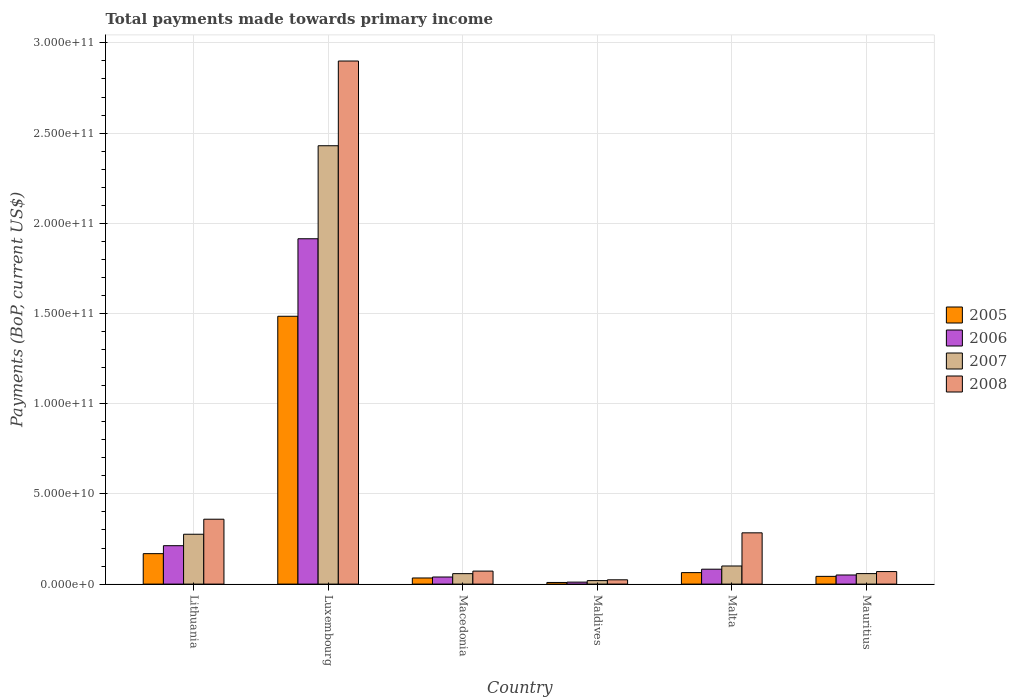How many groups of bars are there?
Ensure brevity in your answer.  6. What is the label of the 2nd group of bars from the left?
Provide a succinct answer. Luxembourg. What is the total payments made towards primary income in 2006 in Macedonia?
Make the answer very short. 3.93e+09. Across all countries, what is the maximum total payments made towards primary income in 2006?
Provide a succinct answer. 1.91e+11. Across all countries, what is the minimum total payments made towards primary income in 2005?
Keep it short and to the point. 9.10e+08. In which country was the total payments made towards primary income in 2006 maximum?
Provide a succinct answer. Luxembourg. In which country was the total payments made towards primary income in 2007 minimum?
Your response must be concise. Maldives. What is the total total payments made towards primary income in 2007 in the graph?
Provide a succinct answer. 2.94e+11. What is the difference between the total payments made towards primary income in 2008 in Lithuania and that in Luxembourg?
Your response must be concise. -2.54e+11. What is the difference between the total payments made towards primary income in 2005 in Lithuania and the total payments made towards primary income in 2006 in Macedonia?
Make the answer very short. 1.29e+1. What is the average total payments made towards primary income in 2005 per country?
Offer a very short reply. 3.00e+1. What is the difference between the total payments made towards primary income of/in 2006 and total payments made towards primary income of/in 2005 in Malta?
Your response must be concise. 1.90e+09. What is the ratio of the total payments made towards primary income in 2007 in Lithuania to that in Maldives?
Offer a very short reply. 14.23. Is the total payments made towards primary income in 2005 in Lithuania less than that in Luxembourg?
Give a very brief answer. Yes. What is the difference between the highest and the second highest total payments made towards primary income in 2007?
Offer a terse response. 2.33e+11. What is the difference between the highest and the lowest total payments made towards primary income in 2006?
Offer a very short reply. 1.90e+11. Is the sum of the total payments made towards primary income in 2005 in Luxembourg and Mauritius greater than the maximum total payments made towards primary income in 2007 across all countries?
Provide a short and direct response. No. What does the 4th bar from the right in Macedonia represents?
Provide a short and direct response. 2005. How many bars are there?
Your answer should be compact. 24. Are all the bars in the graph horizontal?
Give a very brief answer. No. Does the graph contain grids?
Offer a very short reply. Yes. How many legend labels are there?
Give a very brief answer. 4. What is the title of the graph?
Make the answer very short. Total payments made towards primary income. What is the label or title of the Y-axis?
Keep it short and to the point. Payments (BoP, current US$). What is the Payments (BoP, current US$) in 2005 in Lithuania?
Keep it short and to the point. 1.69e+1. What is the Payments (BoP, current US$) in 2006 in Lithuania?
Provide a succinct answer. 2.13e+1. What is the Payments (BoP, current US$) in 2007 in Lithuania?
Keep it short and to the point. 2.76e+1. What is the Payments (BoP, current US$) in 2008 in Lithuania?
Your answer should be very brief. 3.60e+1. What is the Payments (BoP, current US$) in 2005 in Luxembourg?
Give a very brief answer. 1.48e+11. What is the Payments (BoP, current US$) in 2006 in Luxembourg?
Ensure brevity in your answer.  1.91e+11. What is the Payments (BoP, current US$) in 2007 in Luxembourg?
Ensure brevity in your answer.  2.43e+11. What is the Payments (BoP, current US$) in 2008 in Luxembourg?
Provide a succinct answer. 2.90e+11. What is the Payments (BoP, current US$) of 2005 in Macedonia?
Your response must be concise. 3.39e+09. What is the Payments (BoP, current US$) in 2006 in Macedonia?
Your answer should be compact. 3.93e+09. What is the Payments (BoP, current US$) of 2007 in Macedonia?
Provide a short and direct response. 5.80e+09. What is the Payments (BoP, current US$) of 2008 in Macedonia?
Give a very brief answer. 7.21e+09. What is the Payments (BoP, current US$) of 2005 in Maldives?
Your response must be concise. 9.10e+08. What is the Payments (BoP, current US$) in 2006 in Maldives?
Offer a terse response. 1.10e+09. What is the Payments (BoP, current US$) of 2007 in Maldives?
Provide a short and direct response. 1.94e+09. What is the Payments (BoP, current US$) in 2008 in Maldives?
Offer a very short reply. 2.38e+09. What is the Payments (BoP, current US$) of 2005 in Malta?
Make the answer very short. 6.37e+09. What is the Payments (BoP, current US$) of 2006 in Malta?
Give a very brief answer. 8.26e+09. What is the Payments (BoP, current US$) in 2007 in Malta?
Your answer should be very brief. 1.00e+1. What is the Payments (BoP, current US$) in 2008 in Malta?
Your response must be concise. 2.84e+1. What is the Payments (BoP, current US$) in 2005 in Mauritius?
Offer a very short reply. 4.28e+09. What is the Payments (BoP, current US$) in 2006 in Mauritius?
Your response must be concise. 5.05e+09. What is the Payments (BoP, current US$) in 2007 in Mauritius?
Give a very brief answer. 5.82e+09. What is the Payments (BoP, current US$) of 2008 in Mauritius?
Make the answer very short. 6.95e+09. Across all countries, what is the maximum Payments (BoP, current US$) in 2005?
Your answer should be very brief. 1.48e+11. Across all countries, what is the maximum Payments (BoP, current US$) of 2006?
Your response must be concise. 1.91e+11. Across all countries, what is the maximum Payments (BoP, current US$) of 2007?
Ensure brevity in your answer.  2.43e+11. Across all countries, what is the maximum Payments (BoP, current US$) of 2008?
Provide a short and direct response. 2.90e+11. Across all countries, what is the minimum Payments (BoP, current US$) of 2005?
Provide a succinct answer. 9.10e+08. Across all countries, what is the minimum Payments (BoP, current US$) in 2006?
Keep it short and to the point. 1.10e+09. Across all countries, what is the minimum Payments (BoP, current US$) of 2007?
Keep it short and to the point. 1.94e+09. Across all countries, what is the minimum Payments (BoP, current US$) in 2008?
Keep it short and to the point. 2.38e+09. What is the total Payments (BoP, current US$) of 2005 in the graph?
Make the answer very short. 1.80e+11. What is the total Payments (BoP, current US$) in 2006 in the graph?
Offer a terse response. 2.31e+11. What is the total Payments (BoP, current US$) of 2007 in the graph?
Make the answer very short. 2.94e+11. What is the total Payments (BoP, current US$) of 2008 in the graph?
Make the answer very short. 3.71e+11. What is the difference between the Payments (BoP, current US$) of 2005 in Lithuania and that in Luxembourg?
Offer a terse response. -1.32e+11. What is the difference between the Payments (BoP, current US$) in 2006 in Lithuania and that in Luxembourg?
Provide a short and direct response. -1.70e+11. What is the difference between the Payments (BoP, current US$) in 2007 in Lithuania and that in Luxembourg?
Ensure brevity in your answer.  -2.15e+11. What is the difference between the Payments (BoP, current US$) of 2008 in Lithuania and that in Luxembourg?
Make the answer very short. -2.54e+11. What is the difference between the Payments (BoP, current US$) of 2005 in Lithuania and that in Macedonia?
Give a very brief answer. 1.35e+1. What is the difference between the Payments (BoP, current US$) of 2006 in Lithuania and that in Macedonia?
Provide a short and direct response. 1.74e+1. What is the difference between the Payments (BoP, current US$) in 2007 in Lithuania and that in Macedonia?
Offer a terse response. 2.18e+1. What is the difference between the Payments (BoP, current US$) in 2008 in Lithuania and that in Macedonia?
Provide a short and direct response. 2.88e+1. What is the difference between the Payments (BoP, current US$) in 2005 in Lithuania and that in Maldives?
Ensure brevity in your answer.  1.60e+1. What is the difference between the Payments (BoP, current US$) of 2006 in Lithuania and that in Maldives?
Your answer should be very brief. 2.02e+1. What is the difference between the Payments (BoP, current US$) of 2007 in Lithuania and that in Maldives?
Keep it short and to the point. 2.57e+1. What is the difference between the Payments (BoP, current US$) in 2008 in Lithuania and that in Maldives?
Offer a terse response. 3.36e+1. What is the difference between the Payments (BoP, current US$) of 2005 in Lithuania and that in Malta?
Provide a succinct answer. 1.05e+1. What is the difference between the Payments (BoP, current US$) of 2006 in Lithuania and that in Malta?
Ensure brevity in your answer.  1.30e+1. What is the difference between the Payments (BoP, current US$) of 2007 in Lithuania and that in Malta?
Give a very brief answer. 1.76e+1. What is the difference between the Payments (BoP, current US$) of 2008 in Lithuania and that in Malta?
Offer a very short reply. 7.55e+09. What is the difference between the Payments (BoP, current US$) in 2005 in Lithuania and that in Mauritius?
Make the answer very short. 1.26e+1. What is the difference between the Payments (BoP, current US$) in 2006 in Lithuania and that in Mauritius?
Give a very brief answer. 1.62e+1. What is the difference between the Payments (BoP, current US$) in 2007 in Lithuania and that in Mauritius?
Your answer should be very brief. 2.18e+1. What is the difference between the Payments (BoP, current US$) of 2008 in Lithuania and that in Mauritius?
Provide a succinct answer. 2.90e+1. What is the difference between the Payments (BoP, current US$) of 2005 in Luxembourg and that in Macedonia?
Make the answer very short. 1.45e+11. What is the difference between the Payments (BoP, current US$) in 2006 in Luxembourg and that in Macedonia?
Give a very brief answer. 1.87e+11. What is the difference between the Payments (BoP, current US$) of 2007 in Luxembourg and that in Macedonia?
Give a very brief answer. 2.37e+11. What is the difference between the Payments (BoP, current US$) in 2008 in Luxembourg and that in Macedonia?
Your response must be concise. 2.83e+11. What is the difference between the Payments (BoP, current US$) in 2005 in Luxembourg and that in Maldives?
Offer a terse response. 1.48e+11. What is the difference between the Payments (BoP, current US$) in 2006 in Luxembourg and that in Maldives?
Provide a succinct answer. 1.90e+11. What is the difference between the Payments (BoP, current US$) in 2007 in Luxembourg and that in Maldives?
Offer a very short reply. 2.41e+11. What is the difference between the Payments (BoP, current US$) of 2008 in Luxembourg and that in Maldives?
Provide a short and direct response. 2.88e+11. What is the difference between the Payments (BoP, current US$) of 2005 in Luxembourg and that in Malta?
Your answer should be compact. 1.42e+11. What is the difference between the Payments (BoP, current US$) of 2006 in Luxembourg and that in Malta?
Provide a succinct answer. 1.83e+11. What is the difference between the Payments (BoP, current US$) in 2007 in Luxembourg and that in Malta?
Make the answer very short. 2.33e+11. What is the difference between the Payments (BoP, current US$) of 2008 in Luxembourg and that in Malta?
Give a very brief answer. 2.62e+11. What is the difference between the Payments (BoP, current US$) of 2005 in Luxembourg and that in Mauritius?
Provide a succinct answer. 1.44e+11. What is the difference between the Payments (BoP, current US$) in 2006 in Luxembourg and that in Mauritius?
Give a very brief answer. 1.86e+11. What is the difference between the Payments (BoP, current US$) of 2007 in Luxembourg and that in Mauritius?
Make the answer very short. 2.37e+11. What is the difference between the Payments (BoP, current US$) in 2008 in Luxembourg and that in Mauritius?
Offer a terse response. 2.83e+11. What is the difference between the Payments (BoP, current US$) in 2005 in Macedonia and that in Maldives?
Your answer should be very brief. 2.48e+09. What is the difference between the Payments (BoP, current US$) in 2006 in Macedonia and that in Maldives?
Ensure brevity in your answer.  2.83e+09. What is the difference between the Payments (BoP, current US$) of 2007 in Macedonia and that in Maldives?
Keep it short and to the point. 3.86e+09. What is the difference between the Payments (BoP, current US$) of 2008 in Macedonia and that in Maldives?
Provide a short and direct response. 4.83e+09. What is the difference between the Payments (BoP, current US$) in 2005 in Macedonia and that in Malta?
Keep it short and to the point. -2.97e+09. What is the difference between the Payments (BoP, current US$) in 2006 in Macedonia and that in Malta?
Offer a very short reply. -4.33e+09. What is the difference between the Payments (BoP, current US$) in 2007 in Macedonia and that in Malta?
Your answer should be very brief. -4.24e+09. What is the difference between the Payments (BoP, current US$) of 2008 in Macedonia and that in Malta?
Offer a very short reply. -2.12e+1. What is the difference between the Payments (BoP, current US$) of 2005 in Macedonia and that in Mauritius?
Offer a terse response. -8.91e+08. What is the difference between the Payments (BoP, current US$) in 2006 in Macedonia and that in Mauritius?
Give a very brief answer. -1.12e+09. What is the difference between the Payments (BoP, current US$) in 2007 in Macedonia and that in Mauritius?
Your answer should be very brief. -1.97e+07. What is the difference between the Payments (BoP, current US$) of 2008 in Macedonia and that in Mauritius?
Ensure brevity in your answer.  2.59e+08. What is the difference between the Payments (BoP, current US$) in 2005 in Maldives and that in Malta?
Keep it short and to the point. -5.46e+09. What is the difference between the Payments (BoP, current US$) in 2006 in Maldives and that in Malta?
Your response must be concise. -7.16e+09. What is the difference between the Payments (BoP, current US$) in 2007 in Maldives and that in Malta?
Make the answer very short. -8.10e+09. What is the difference between the Payments (BoP, current US$) of 2008 in Maldives and that in Malta?
Ensure brevity in your answer.  -2.60e+1. What is the difference between the Payments (BoP, current US$) in 2005 in Maldives and that in Mauritius?
Your answer should be very brief. -3.37e+09. What is the difference between the Payments (BoP, current US$) of 2006 in Maldives and that in Mauritius?
Provide a short and direct response. -3.95e+09. What is the difference between the Payments (BoP, current US$) in 2007 in Maldives and that in Mauritius?
Offer a terse response. -3.88e+09. What is the difference between the Payments (BoP, current US$) in 2008 in Maldives and that in Mauritius?
Ensure brevity in your answer.  -4.57e+09. What is the difference between the Payments (BoP, current US$) in 2005 in Malta and that in Mauritius?
Keep it short and to the point. 2.08e+09. What is the difference between the Payments (BoP, current US$) of 2006 in Malta and that in Mauritius?
Offer a very short reply. 3.21e+09. What is the difference between the Payments (BoP, current US$) of 2007 in Malta and that in Mauritius?
Ensure brevity in your answer.  4.22e+09. What is the difference between the Payments (BoP, current US$) of 2008 in Malta and that in Mauritius?
Your answer should be very brief. 2.15e+1. What is the difference between the Payments (BoP, current US$) in 2005 in Lithuania and the Payments (BoP, current US$) in 2006 in Luxembourg?
Make the answer very short. -1.75e+11. What is the difference between the Payments (BoP, current US$) of 2005 in Lithuania and the Payments (BoP, current US$) of 2007 in Luxembourg?
Offer a terse response. -2.26e+11. What is the difference between the Payments (BoP, current US$) in 2005 in Lithuania and the Payments (BoP, current US$) in 2008 in Luxembourg?
Your answer should be very brief. -2.73e+11. What is the difference between the Payments (BoP, current US$) of 2006 in Lithuania and the Payments (BoP, current US$) of 2007 in Luxembourg?
Ensure brevity in your answer.  -2.22e+11. What is the difference between the Payments (BoP, current US$) of 2006 in Lithuania and the Payments (BoP, current US$) of 2008 in Luxembourg?
Make the answer very short. -2.69e+11. What is the difference between the Payments (BoP, current US$) in 2007 in Lithuania and the Payments (BoP, current US$) in 2008 in Luxembourg?
Give a very brief answer. -2.62e+11. What is the difference between the Payments (BoP, current US$) of 2005 in Lithuania and the Payments (BoP, current US$) of 2006 in Macedonia?
Your response must be concise. 1.29e+1. What is the difference between the Payments (BoP, current US$) of 2005 in Lithuania and the Payments (BoP, current US$) of 2007 in Macedonia?
Provide a succinct answer. 1.11e+1. What is the difference between the Payments (BoP, current US$) in 2005 in Lithuania and the Payments (BoP, current US$) in 2008 in Macedonia?
Ensure brevity in your answer.  9.67e+09. What is the difference between the Payments (BoP, current US$) in 2006 in Lithuania and the Payments (BoP, current US$) in 2007 in Macedonia?
Your answer should be compact. 1.55e+1. What is the difference between the Payments (BoP, current US$) in 2006 in Lithuania and the Payments (BoP, current US$) in 2008 in Macedonia?
Offer a terse response. 1.41e+1. What is the difference between the Payments (BoP, current US$) in 2007 in Lithuania and the Payments (BoP, current US$) in 2008 in Macedonia?
Provide a succinct answer. 2.04e+1. What is the difference between the Payments (BoP, current US$) in 2005 in Lithuania and the Payments (BoP, current US$) in 2006 in Maldives?
Give a very brief answer. 1.58e+1. What is the difference between the Payments (BoP, current US$) in 2005 in Lithuania and the Payments (BoP, current US$) in 2007 in Maldives?
Your answer should be compact. 1.49e+1. What is the difference between the Payments (BoP, current US$) in 2005 in Lithuania and the Payments (BoP, current US$) in 2008 in Maldives?
Your response must be concise. 1.45e+1. What is the difference between the Payments (BoP, current US$) in 2006 in Lithuania and the Payments (BoP, current US$) in 2007 in Maldives?
Keep it short and to the point. 1.93e+1. What is the difference between the Payments (BoP, current US$) of 2006 in Lithuania and the Payments (BoP, current US$) of 2008 in Maldives?
Your answer should be compact. 1.89e+1. What is the difference between the Payments (BoP, current US$) of 2007 in Lithuania and the Payments (BoP, current US$) of 2008 in Maldives?
Your answer should be very brief. 2.53e+1. What is the difference between the Payments (BoP, current US$) in 2005 in Lithuania and the Payments (BoP, current US$) in 2006 in Malta?
Give a very brief answer. 8.62e+09. What is the difference between the Payments (BoP, current US$) of 2005 in Lithuania and the Payments (BoP, current US$) of 2007 in Malta?
Your answer should be compact. 6.84e+09. What is the difference between the Payments (BoP, current US$) of 2005 in Lithuania and the Payments (BoP, current US$) of 2008 in Malta?
Offer a very short reply. -1.15e+1. What is the difference between the Payments (BoP, current US$) in 2006 in Lithuania and the Payments (BoP, current US$) in 2007 in Malta?
Your answer should be very brief. 1.12e+1. What is the difference between the Payments (BoP, current US$) of 2006 in Lithuania and the Payments (BoP, current US$) of 2008 in Malta?
Offer a very short reply. -7.13e+09. What is the difference between the Payments (BoP, current US$) of 2007 in Lithuania and the Payments (BoP, current US$) of 2008 in Malta?
Offer a terse response. -7.77e+08. What is the difference between the Payments (BoP, current US$) in 2005 in Lithuania and the Payments (BoP, current US$) in 2006 in Mauritius?
Provide a succinct answer. 1.18e+1. What is the difference between the Payments (BoP, current US$) in 2005 in Lithuania and the Payments (BoP, current US$) in 2007 in Mauritius?
Provide a short and direct response. 1.11e+1. What is the difference between the Payments (BoP, current US$) in 2005 in Lithuania and the Payments (BoP, current US$) in 2008 in Mauritius?
Make the answer very short. 9.93e+09. What is the difference between the Payments (BoP, current US$) in 2006 in Lithuania and the Payments (BoP, current US$) in 2007 in Mauritius?
Keep it short and to the point. 1.55e+1. What is the difference between the Payments (BoP, current US$) of 2006 in Lithuania and the Payments (BoP, current US$) of 2008 in Mauritius?
Your answer should be very brief. 1.43e+1. What is the difference between the Payments (BoP, current US$) of 2007 in Lithuania and the Payments (BoP, current US$) of 2008 in Mauritius?
Offer a terse response. 2.07e+1. What is the difference between the Payments (BoP, current US$) of 2005 in Luxembourg and the Payments (BoP, current US$) of 2006 in Macedonia?
Provide a short and direct response. 1.45e+11. What is the difference between the Payments (BoP, current US$) of 2005 in Luxembourg and the Payments (BoP, current US$) of 2007 in Macedonia?
Your answer should be compact. 1.43e+11. What is the difference between the Payments (BoP, current US$) in 2005 in Luxembourg and the Payments (BoP, current US$) in 2008 in Macedonia?
Make the answer very short. 1.41e+11. What is the difference between the Payments (BoP, current US$) in 2006 in Luxembourg and the Payments (BoP, current US$) in 2007 in Macedonia?
Offer a very short reply. 1.86e+11. What is the difference between the Payments (BoP, current US$) of 2006 in Luxembourg and the Payments (BoP, current US$) of 2008 in Macedonia?
Your answer should be very brief. 1.84e+11. What is the difference between the Payments (BoP, current US$) in 2007 in Luxembourg and the Payments (BoP, current US$) in 2008 in Macedonia?
Your answer should be compact. 2.36e+11. What is the difference between the Payments (BoP, current US$) of 2005 in Luxembourg and the Payments (BoP, current US$) of 2006 in Maldives?
Provide a short and direct response. 1.47e+11. What is the difference between the Payments (BoP, current US$) of 2005 in Luxembourg and the Payments (BoP, current US$) of 2007 in Maldives?
Make the answer very short. 1.47e+11. What is the difference between the Payments (BoP, current US$) of 2005 in Luxembourg and the Payments (BoP, current US$) of 2008 in Maldives?
Keep it short and to the point. 1.46e+11. What is the difference between the Payments (BoP, current US$) in 2006 in Luxembourg and the Payments (BoP, current US$) in 2007 in Maldives?
Provide a short and direct response. 1.89e+11. What is the difference between the Payments (BoP, current US$) in 2006 in Luxembourg and the Payments (BoP, current US$) in 2008 in Maldives?
Make the answer very short. 1.89e+11. What is the difference between the Payments (BoP, current US$) of 2007 in Luxembourg and the Payments (BoP, current US$) of 2008 in Maldives?
Your response must be concise. 2.41e+11. What is the difference between the Payments (BoP, current US$) of 2005 in Luxembourg and the Payments (BoP, current US$) of 2006 in Malta?
Your answer should be very brief. 1.40e+11. What is the difference between the Payments (BoP, current US$) in 2005 in Luxembourg and the Payments (BoP, current US$) in 2007 in Malta?
Ensure brevity in your answer.  1.38e+11. What is the difference between the Payments (BoP, current US$) in 2005 in Luxembourg and the Payments (BoP, current US$) in 2008 in Malta?
Ensure brevity in your answer.  1.20e+11. What is the difference between the Payments (BoP, current US$) of 2006 in Luxembourg and the Payments (BoP, current US$) of 2007 in Malta?
Your response must be concise. 1.81e+11. What is the difference between the Payments (BoP, current US$) of 2006 in Luxembourg and the Payments (BoP, current US$) of 2008 in Malta?
Give a very brief answer. 1.63e+11. What is the difference between the Payments (BoP, current US$) in 2007 in Luxembourg and the Payments (BoP, current US$) in 2008 in Malta?
Give a very brief answer. 2.15e+11. What is the difference between the Payments (BoP, current US$) in 2005 in Luxembourg and the Payments (BoP, current US$) in 2006 in Mauritius?
Your answer should be compact. 1.43e+11. What is the difference between the Payments (BoP, current US$) in 2005 in Luxembourg and the Payments (BoP, current US$) in 2007 in Mauritius?
Your answer should be very brief. 1.43e+11. What is the difference between the Payments (BoP, current US$) of 2005 in Luxembourg and the Payments (BoP, current US$) of 2008 in Mauritius?
Provide a succinct answer. 1.42e+11. What is the difference between the Payments (BoP, current US$) in 2006 in Luxembourg and the Payments (BoP, current US$) in 2007 in Mauritius?
Your answer should be very brief. 1.86e+11. What is the difference between the Payments (BoP, current US$) in 2006 in Luxembourg and the Payments (BoP, current US$) in 2008 in Mauritius?
Your answer should be compact. 1.84e+11. What is the difference between the Payments (BoP, current US$) in 2007 in Luxembourg and the Payments (BoP, current US$) in 2008 in Mauritius?
Keep it short and to the point. 2.36e+11. What is the difference between the Payments (BoP, current US$) of 2005 in Macedonia and the Payments (BoP, current US$) of 2006 in Maldives?
Provide a succinct answer. 2.29e+09. What is the difference between the Payments (BoP, current US$) of 2005 in Macedonia and the Payments (BoP, current US$) of 2007 in Maldives?
Ensure brevity in your answer.  1.45e+09. What is the difference between the Payments (BoP, current US$) of 2005 in Macedonia and the Payments (BoP, current US$) of 2008 in Maldives?
Your response must be concise. 1.01e+09. What is the difference between the Payments (BoP, current US$) in 2006 in Macedonia and the Payments (BoP, current US$) in 2007 in Maldives?
Make the answer very short. 1.99e+09. What is the difference between the Payments (BoP, current US$) in 2006 in Macedonia and the Payments (BoP, current US$) in 2008 in Maldives?
Offer a terse response. 1.55e+09. What is the difference between the Payments (BoP, current US$) in 2007 in Macedonia and the Payments (BoP, current US$) in 2008 in Maldives?
Your response must be concise. 3.42e+09. What is the difference between the Payments (BoP, current US$) in 2005 in Macedonia and the Payments (BoP, current US$) in 2006 in Malta?
Your answer should be compact. -4.87e+09. What is the difference between the Payments (BoP, current US$) in 2005 in Macedonia and the Payments (BoP, current US$) in 2007 in Malta?
Offer a very short reply. -6.65e+09. What is the difference between the Payments (BoP, current US$) of 2005 in Macedonia and the Payments (BoP, current US$) of 2008 in Malta?
Your answer should be very brief. -2.50e+1. What is the difference between the Payments (BoP, current US$) of 2006 in Macedonia and the Payments (BoP, current US$) of 2007 in Malta?
Give a very brief answer. -6.11e+09. What is the difference between the Payments (BoP, current US$) in 2006 in Macedonia and the Payments (BoP, current US$) in 2008 in Malta?
Keep it short and to the point. -2.45e+1. What is the difference between the Payments (BoP, current US$) in 2007 in Macedonia and the Payments (BoP, current US$) in 2008 in Malta?
Your response must be concise. -2.26e+1. What is the difference between the Payments (BoP, current US$) in 2005 in Macedonia and the Payments (BoP, current US$) in 2006 in Mauritius?
Your answer should be compact. -1.66e+09. What is the difference between the Payments (BoP, current US$) in 2005 in Macedonia and the Payments (BoP, current US$) in 2007 in Mauritius?
Your answer should be very brief. -2.43e+09. What is the difference between the Payments (BoP, current US$) in 2005 in Macedonia and the Payments (BoP, current US$) in 2008 in Mauritius?
Your response must be concise. -3.55e+09. What is the difference between the Payments (BoP, current US$) in 2006 in Macedonia and the Payments (BoP, current US$) in 2007 in Mauritius?
Provide a short and direct response. -1.89e+09. What is the difference between the Payments (BoP, current US$) of 2006 in Macedonia and the Payments (BoP, current US$) of 2008 in Mauritius?
Your answer should be compact. -3.02e+09. What is the difference between the Payments (BoP, current US$) in 2007 in Macedonia and the Payments (BoP, current US$) in 2008 in Mauritius?
Give a very brief answer. -1.15e+09. What is the difference between the Payments (BoP, current US$) of 2005 in Maldives and the Payments (BoP, current US$) of 2006 in Malta?
Offer a very short reply. -7.35e+09. What is the difference between the Payments (BoP, current US$) in 2005 in Maldives and the Payments (BoP, current US$) in 2007 in Malta?
Make the answer very short. -9.13e+09. What is the difference between the Payments (BoP, current US$) of 2005 in Maldives and the Payments (BoP, current US$) of 2008 in Malta?
Offer a very short reply. -2.75e+1. What is the difference between the Payments (BoP, current US$) in 2006 in Maldives and the Payments (BoP, current US$) in 2007 in Malta?
Keep it short and to the point. -8.94e+09. What is the difference between the Payments (BoP, current US$) of 2006 in Maldives and the Payments (BoP, current US$) of 2008 in Malta?
Offer a terse response. -2.73e+1. What is the difference between the Payments (BoP, current US$) in 2007 in Maldives and the Payments (BoP, current US$) in 2008 in Malta?
Offer a very short reply. -2.65e+1. What is the difference between the Payments (BoP, current US$) in 2005 in Maldives and the Payments (BoP, current US$) in 2006 in Mauritius?
Your answer should be compact. -4.14e+09. What is the difference between the Payments (BoP, current US$) of 2005 in Maldives and the Payments (BoP, current US$) of 2007 in Mauritius?
Give a very brief answer. -4.91e+09. What is the difference between the Payments (BoP, current US$) in 2005 in Maldives and the Payments (BoP, current US$) in 2008 in Mauritius?
Keep it short and to the point. -6.04e+09. What is the difference between the Payments (BoP, current US$) of 2006 in Maldives and the Payments (BoP, current US$) of 2007 in Mauritius?
Provide a short and direct response. -4.72e+09. What is the difference between the Payments (BoP, current US$) of 2006 in Maldives and the Payments (BoP, current US$) of 2008 in Mauritius?
Provide a short and direct response. -5.84e+09. What is the difference between the Payments (BoP, current US$) in 2007 in Maldives and the Payments (BoP, current US$) in 2008 in Mauritius?
Make the answer very short. -5.00e+09. What is the difference between the Payments (BoP, current US$) of 2005 in Malta and the Payments (BoP, current US$) of 2006 in Mauritius?
Your answer should be compact. 1.32e+09. What is the difference between the Payments (BoP, current US$) of 2005 in Malta and the Payments (BoP, current US$) of 2007 in Mauritius?
Your response must be concise. 5.49e+08. What is the difference between the Payments (BoP, current US$) of 2005 in Malta and the Payments (BoP, current US$) of 2008 in Mauritius?
Make the answer very short. -5.81e+08. What is the difference between the Payments (BoP, current US$) of 2006 in Malta and the Payments (BoP, current US$) of 2007 in Mauritius?
Offer a terse response. 2.45e+09. What is the difference between the Payments (BoP, current US$) of 2006 in Malta and the Payments (BoP, current US$) of 2008 in Mauritius?
Offer a terse response. 1.32e+09. What is the difference between the Payments (BoP, current US$) in 2007 in Malta and the Payments (BoP, current US$) in 2008 in Mauritius?
Provide a short and direct response. 3.09e+09. What is the average Payments (BoP, current US$) in 2005 per country?
Ensure brevity in your answer.  3.00e+1. What is the average Payments (BoP, current US$) in 2006 per country?
Ensure brevity in your answer.  3.85e+1. What is the average Payments (BoP, current US$) of 2007 per country?
Keep it short and to the point. 4.90e+1. What is the average Payments (BoP, current US$) of 2008 per country?
Provide a short and direct response. 6.18e+1. What is the difference between the Payments (BoP, current US$) of 2005 and Payments (BoP, current US$) of 2006 in Lithuania?
Keep it short and to the point. -4.41e+09. What is the difference between the Payments (BoP, current US$) in 2005 and Payments (BoP, current US$) in 2007 in Lithuania?
Provide a short and direct response. -1.08e+1. What is the difference between the Payments (BoP, current US$) in 2005 and Payments (BoP, current US$) in 2008 in Lithuania?
Make the answer very short. -1.91e+1. What is the difference between the Payments (BoP, current US$) in 2006 and Payments (BoP, current US$) in 2007 in Lithuania?
Your response must be concise. -6.35e+09. What is the difference between the Payments (BoP, current US$) of 2006 and Payments (BoP, current US$) of 2008 in Lithuania?
Provide a succinct answer. -1.47e+1. What is the difference between the Payments (BoP, current US$) in 2007 and Payments (BoP, current US$) in 2008 in Lithuania?
Your response must be concise. -8.33e+09. What is the difference between the Payments (BoP, current US$) in 2005 and Payments (BoP, current US$) in 2006 in Luxembourg?
Your answer should be compact. -4.30e+1. What is the difference between the Payments (BoP, current US$) of 2005 and Payments (BoP, current US$) of 2007 in Luxembourg?
Provide a short and direct response. -9.45e+1. What is the difference between the Payments (BoP, current US$) of 2005 and Payments (BoP, current US$) of 2008 in Luxembourg?
Your answer should be compact. -1.41e+11. What is the difference between the Payments (BoP, current US$) of 2006 and Payments (BoP, current US$) of 2007 in Luxembourg?
Your answer should be compact. -5.16e+1. What is the difference between the Payments (BoP, current US$) of 2006 and Payments (BoP, current US$) of 2008 in Luxembourg?
Your response must be concise. -9.85e+1. What is the difference between the Payments (BoP, current US$) in 2007 and Payments (BoP, current US$) in 2008 in Luxembourg?
Provide a succinct answer. -4.70e+1. What is the difference between the Payments (BoP, current US$) in 2005 and Payments (BoP, current US$) in 2006 in Macedonia?
Give a very brief answer. -5.40e+08. What is the difference between the Payments (BoP, current US$) of 2005 and Payments (BoP, current US$) of 2007 in Macedonia?
Keep it short and to the point. -2.41e+09. What is the difference between the Payments (BoP, current US$) in 2005 and Payments (BoP, current US$) in 2008 in Macedonia?
Keep it short and to the point. -3.81e+09. What is the difference between the Payments (BoP, current US$) in 2006 and Payments (BoP, current US$) in 2007 in Macedonia?
Ensure brevity in your answer.  -1.87e+09. What is the difference between the Payments (BoP, current US$) in 2006 and Payments (BoP, current US$) in 2008 in Macedonia?
Your answer should be compact. -3.27e+09. What is the difference between the Payments (BoP, current US$) in 2007 and Payments (BoP, current US$) in 2008 in Macedonia?
Make the answer very short. -1.41e+09. What is the difference between the Payments (BoP, current US$) of 2005 and Payments (BoP, current US$) of 2006 in Maldives?
Ensure brevity in your answer.  -1.92e+08. What is the difference between the Payments (BoP, current US$) of 2005 and Payments (BoP, current US$) of 2007 in Maldives?
Keep it short and to the point. -1.03e+09. What is the difference between the Payments (BoP, current US$) in 2005 and Payments (BoP, current US$) in 2008 in Maldives?
Your answer should be very brief. -1.47e+09. What is the difference between the Payments (BoP, current US$) in 2006 and Payments (BoP, current US$) in 2007 in Maldives?
Provide a succinct answer. -8.40e+08. What is the difference between the Payments (BoP, current US$) of 2006 and Payments (BoP, current US$) of 2008 in Maldives?
Ensure brevity in your answer.  -1.28e+09. What is the difference between the Payments (BoP, current US$) of 2007 and Payments (BoP, current US$) of 2008 in Maldives?
Provide a short and direct response. -4.38e+08. What is the difference between the Payments (BoP, current US$) in 2005 and Payments (BoP, current US$) in 2006 in Malta?
Your response must be concise. -1.90e+09. What is the difference between the Payments (BoP, current US$) in 2005 and Payments (BoP, current US$) in 2007 in Malta?
Provide a short and direct response. -3.67e+09. What is the difference between the Payments (BoP, current US$) of 2005 and Payments (BoP, current US$) of 2008 in Malta?
Your answer should be very brief. -2.21e+1. What is the difference between the Payments (BoP, current US$) of 2006 and Payments (BoP, current US$) of 2007 in Malta?
Provide a succinct answer. -1.78e+09. What is the difference between the Payments (BoP, current US$) of 2006 and Payments (BoP, current US$) of 2008 in Malta?
Give a very brief answer. -2.02e+1. What is the difference between the Payments (BoP, current US$) in 2007 and Payments (BoP, current US$) in 2008 in Malta?
Keep it short and to the point. -1.84e+1. What is the difference between the Payments (BoP, current US$) in 2005 and Payments (BoP, current US$) in 2006 in Mauritius?
Your answer should be compact. -7.65e+08. What is the difference between the Payments (BoP, current US$) in 2005 and Payments (BoP, current US$) in 2007 in Mauritius?
Your answer should be very brief. -1.53e+09. What is the difference between the Payments (BoP, current US$) of 2005 and Payments (BoP, current US$) of 2008 in Mauritius?
Make the answer very short. -2.66e+09. What is the difference between the Payments (BoP, current US$) in 2006 and Payments (BoP, current US$) in 2007 in Mauritius?
Make the answer very short. -7.69e+08. What is the difference between the Payments (BoP, current US$) of 2006 and Payments (BoP, current US$) of 2008 in Mauritius?
Keep it short and to the point. -1.90e+09. What is the difference between the Payments (BoP, current US$) in 2007 and Payments (BoP, current US$) in 2008 in Mauritius?
Provide a short and direct response. -1.13e+09. What is the ratio of the Payments (BoP, current US$) of 2005 in Lithuania to that in Luxembourg?
Offer a very short reply. 0.11. What is the ratio of the Payments (BoP, current US$) in 2006 in Lithuania to that in Luxembourg?
Ensure brevity in your answer.  0.11. What is the ratio of the Payments (BoP, current US$) of 2007 in Lithuania to that in Luxembourg?
Ensure brevity in your answer.  0.11. What is the ratio of the Payments (BoP, current US$) of 2008 in Lithuania to that in Luxembourg?
Provide a short and direct response. 0.12. What is the ratio of the Payments (BoP, current US$) in 2005 in Lithuania to that in Macedonia?
Provide a short and direct response. 4.98. What is the ratio of the Payments (BoP, current US$) in 2006 in Lithuania to that in Macedonia?
Your answer should be compact. 5.41. What is the ratio of the Payments (BoP, current US$) of 2007 in Lithuania to that in Macedonia?
Provide a succinct answer. 4.77. What is the ratio of the Payments (BoP, current US$) of 2008 in Lithuania to that in Macedonia?
Your answer should be compact. 4.99. What is the ratio of the Payments (BoP, current US$) of 2005 in Lithuania to that in Maldives?
Offer a terse response. 18.54. What is the ratio of the Payments (BoP, current US$) of 2006 in Lithuania to that in Maldives?
Your answer should be very brief. 19.31. What is the ratio of the Payments (BoP, current US$) in 2007 in Lithuania to that in Maldives?
Offer a terse response. 14.23. What is the ratio of the Payments (BoP, current US$) of 2008 in Lithuania to that in Maldives?
Provide a succinct answer. 15.11. What is the ratio of the Payments (BoP, current US$) in 2005 in Lithuania to that in Malta?
Offer a terse response. 2.65. What is the ratio of the Payments (BoP, current US$) of 2006 in Lithuania to that in Malta?
Provide a succinct answer. 2.58. What is the ratio of the Payments (BoP, current US$) in 2007 in Lithuania to that in Malta?
Your response must be concise. 2.75. What is the ratio of the Payments (BoP, current US$) of 2008 in Lithuania to that in Malta?
Ensure brevity in your answer.  1.27. What is the ratio of the Payments (BoP, current US$) in 2005 in Lithuania to that in Mauritius?
Keep it short and to the point. 3.94. What is the ratio of the Payments (BoP, current US$) of 2006 in Lithuania to that in Mauritius?
Make the answer very short. 4.22. What is the ratio of the Payments (BoP, current US$) in 2007 in Lithuania to that in Mauritius?
Offer a very short reply. 4.75. What is the ratio of the Payments (BoP, current US$) of 2008 in Lithuania to that in Mauritius?
Make the answer very short. 5.18. What is the ratio of the Payments (BoP, current US$) of 2005 in Luxembourg to that in Macedonia?
Your answer should be compact. 43.76. What is the ratio of the Payments (BoP, current US$) of 2006 in Luxembourg to that in Macedonia?
Your answer should be compact. 48.68. What is the ratio of the Payments (BoP, current US$) of 2007 in Luxembourg to that in Macedonia?
Offer a terse response. 41.91. What is the ratio of the Payments (BoP, current US$) in 2008 in Luxembourg to that in Macedonia?
Offer a very short reply. 40.24. What is the ratio of the Payments (BoP, current US$) of 2005 in Luxembourg to that in Maldives?
Provide a short and direct response. 163.08. What is the ratio of the Payments (BoP, current US$) in 2006 in Luxembourg to that in Maldives?
Your response must be concise. 173.58. What is the ratio of the Payments (BoP, current US$) of 2007 in Luxembourg to that in Maldives?
Your answer should be very brief. 125.06. What is the ratio of the Payments (BoP, current US$) in 2008 in Luxembourg to that in Maldives?
Provide a succinct answer. 121.79. What is the ratio of the Payments (BoP, current US$) of 2005 in Luxembourg to that in Malta?
Provide a succinct answer. 23.32. What is the ratio of the Payments (BoP, current US$) in 2006 in Luxembourg to that in Malta?
Ensure brevity in your answer.  23.16. What is the ratio of the Payments (BoP, current US$) in 2007 in Luxembourg to that in Malta?
Your answer should be very brief. 24.2. What is the ratio of the Payments (BoP, current US$) in 2008 in Luxembourg to that in Malta?
Provide a succinct answer. 10.2. What is the ratio of the Payments (BoP, current US$) in 2005 in Luxembourg to that in Mauritius?
Keep it short and to the point. 34.65. What is the ratio of the Payments (BoP, current US$) in 2006 in Luxembourg to that in Mauritius?
Provide a short and direct response. 37.91. What is the ratio of the Payments (BoP, current US$) in 2007 in Luxembourg to that in Mauritius?
Give a very brief answer. 41.76. What is the ratio of the Payments (BoP, current US$) in 2008 in Luxembourg to that in Mauritius?
Provide a short and direct response. 41.73. What is the ratio of the Payments (BoP, current US$) of 2005 in Macedonia to that in Maldives?
Your answer should be compact. 3.73. What is the ratio of the Payments (BoP, current US$) of 2006 in Macedonia to that in Maldives?
Your answer should be very brief. 3.57. What is the ratio of the Payments (BoP, current US$) of 2007 in Macedonia to that in Maldives?
Provide a short and direct response. 2.98. What is the ratio of the Payments (BoP, current US$) of 2008 in Macedonia to that in Maldives?
Your answer should be compact. 3.03. What is the ratio of the Payments (BoP, current US$) of 2005 in Macedonia to that in Malta?
Your answer should be very brief. 0.53. What is the ratio of the Payments (BoP, current US$) of 2006 in Macedonia to that in Malta?
Give a very brief answer. 0.48. What is the ratio of the Payments (BoP, current US$) of 2007 in Macedonia to that in Malta?
Ensure brevity in your answer.  0.58. What is the ratio of the Payments (BoP, current US$) of 2008 in Macedonia to that in Malta?
Make the answer very short. 0.25. What is the ratio of the Payments (BoP, current US$) of 2005 in Macedonia to that in Mauritius?
Offer a very short reply. 0.79. What is the ratio of the Payments (BoP, current US$) of 2006 in Macedonia to that in Mauritius?
Your answer should be very brief. 0.78. What is the ratio of the Payments (BoP, current US$) of 2008 in Macedonia to that in Mauritius?
Keep it short and to the point. 1.04. What is the ratio of the Payments (BoP, current US$) of 2005 in Maldives to that in Malta?
Your answer should be very brief. 0.14. What is the ratio of the Payments (BoP, current US$) of 2006 in Maldives to that in Malta?
Your answer should be very brief. 0.13. What is the ratio of the Payments (BoP, current US$) in 2007 in Maldives to that in Malta?
Make the answer very short. 0.19. What is the ratio of the Payments (BoP, current US$) of 2008 in Maldives to that in Malta?
Your response must be concise. 0.08. What is the ratio of the Payments (BoP, current US$) in 2005 in Maldives to that in Mauritius?
Ensure brevity in your answer.  0.21. What is the ratio of the Payments (BoP, current US$) in 2006 in Maldives to that in Mauritius?
Provide a short and direct response. 0.22. What is the ratio of the Payments (BoP, current US$) in 2007 in Maldives to that in Mauritius?
Keep it short and to the point. 0.33. What is the ratio of the Payments (BoP, current US$) in 2008 in Maldives to that in Mauritius?
Make the answer very short. 0.34. What is the ratio of the Payments (BoP, current US$) in 2005 in Malta to that in Mauritius?
Your response must be concise. 1.49. What is the ratio of the Payments (BoP, current US$) in 2006 in Malta to that in Mauritius?
Keep it short and to the point. 1.64. What is the ratio of the Payments (BoP, current US$) in 2007 in Malta to that in Mauritius?
Provide a succinct answer. 1.73. What is the ratio of the Payments (BoP, current US$) of 2008 in Malta to that in Mauritius?
Provide a short and direct response. 4.09. What is the difference between the highest and the second highest Payments (BoP, current US$) of 2005?
Your answer should be compact. 1.32e+11. What is the difference between the highest and the second highest Payments (BoP, current US$) of 2006?
Provide a succinct answer. 1.70e+11. What is the difference between the highest and the second highest Payments (BoP, current US$) in 2007?
Make the answer very short. 2.15e+11. What is the difference between the highest and the second highest Payments (BoP, current US$) of 2008?
Ensure brevity in your answer.  2.54e+11. What is the difference between the highest and the lowest Payments (BoP, current US$) in 2005?
Keep it short and to the point. 1.48e+11. What is the difference between the highest and the lowest Payments (BoP, current US$) in 2006?
Give a very brief answer. 1.90e+11. What is the difference between the highest and the lowest Payments (BoP, current US$) of 2007?
Ensure brevity in your answer.  2.41e+11. What is the difference between the highest and the lowest Payments (BoP, current US$) of 2008?
Provide a succinct answer. 2.88e+11. 